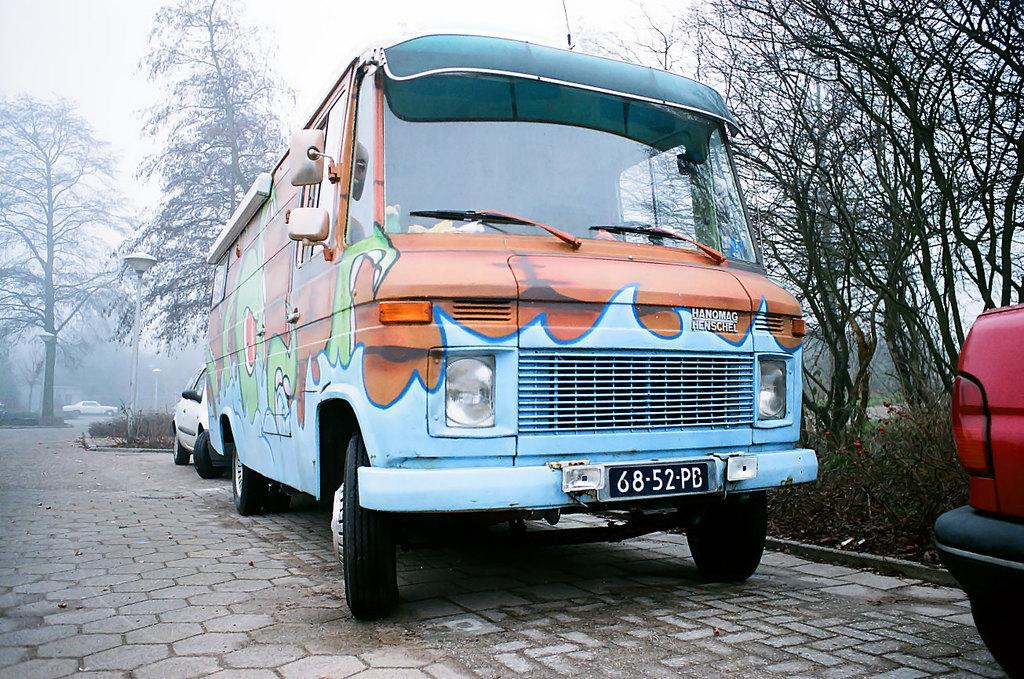<image>
Offer a succinct explanation of the picture presented. Blue and orange van with a plate which says 6852PE on it. 